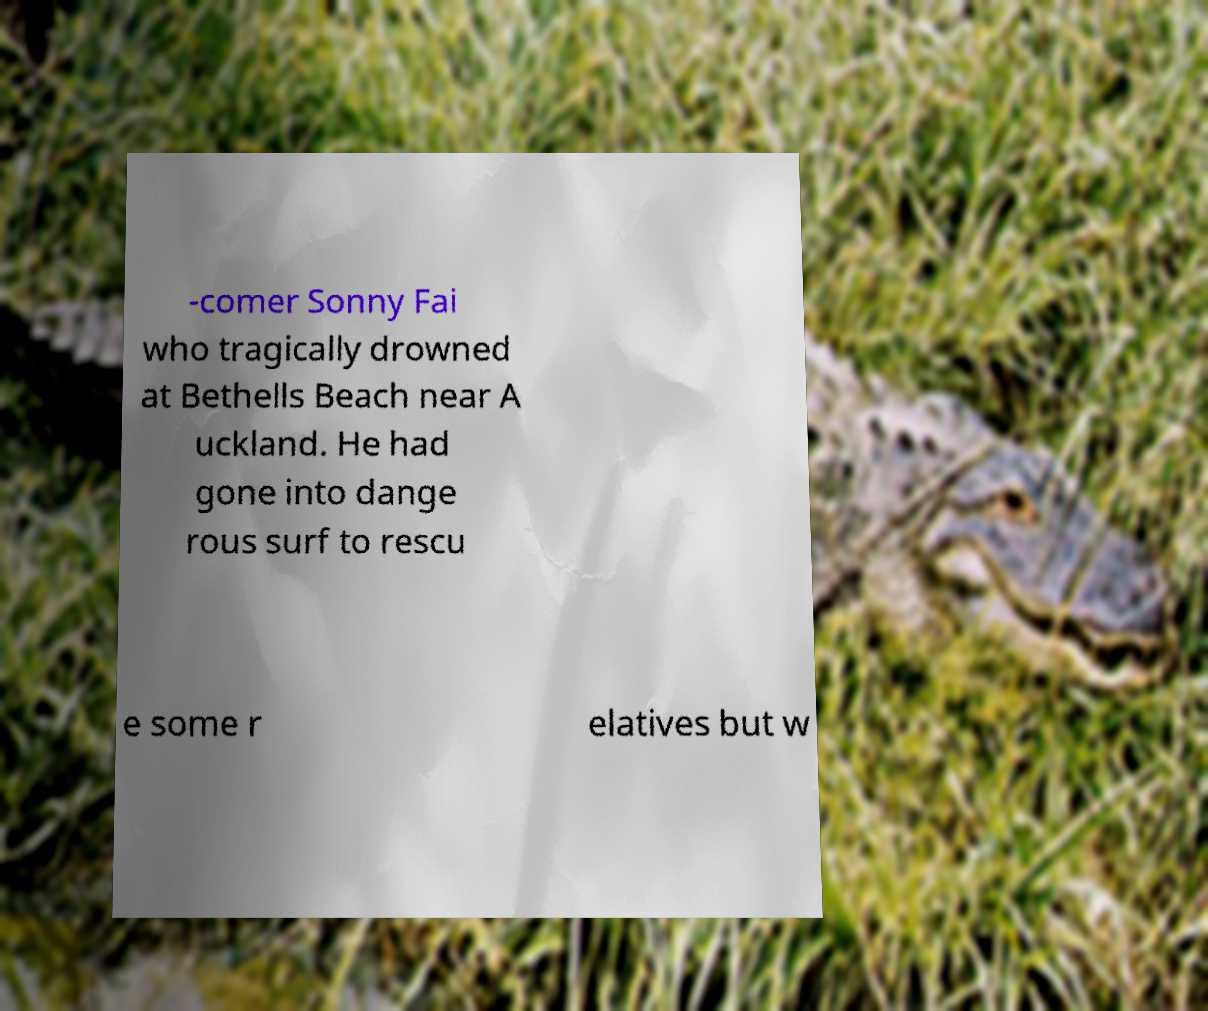Please read and relay the text visible in this image. What does it say? -comer Sonny Fai who tragically drowned at Bethells Beach near A uckland. He had gone into dange rous surf to rescu e some r elatives but w 